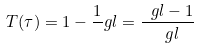<formula> <loc_0><loc_0><loc_500><loc_500>T ( \tau ) = 1 - \frac { 1 } { \ } g l = \frac { \ g l - 1 } { \ g l }</formula> 